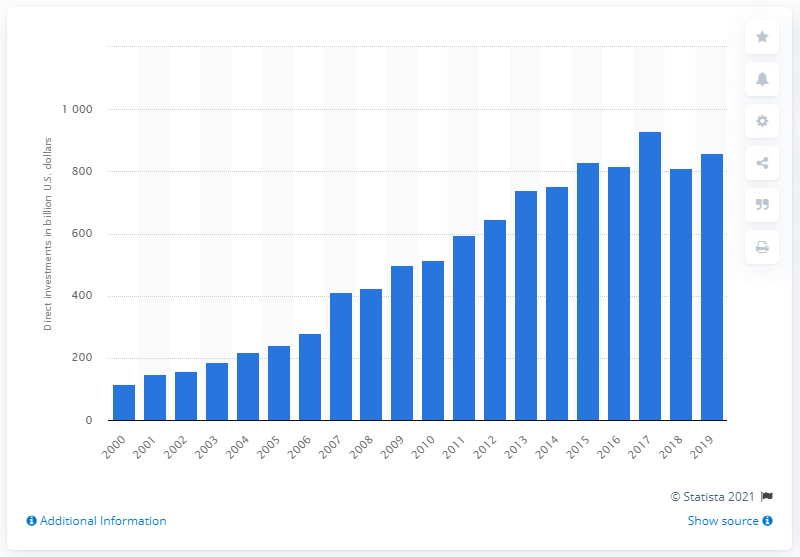List a handful of essential elements in this visual. In 2019, the value of investments made in the Netherlands was 860.53... 